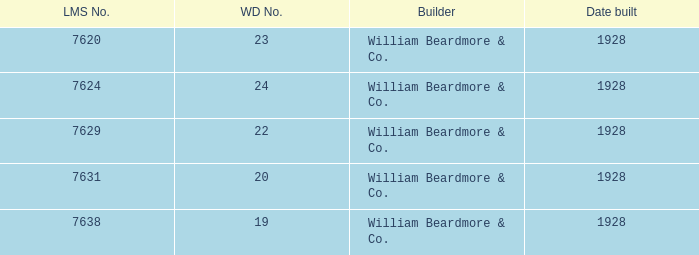Identify the lms figure for the serial number 37 7624.0. 